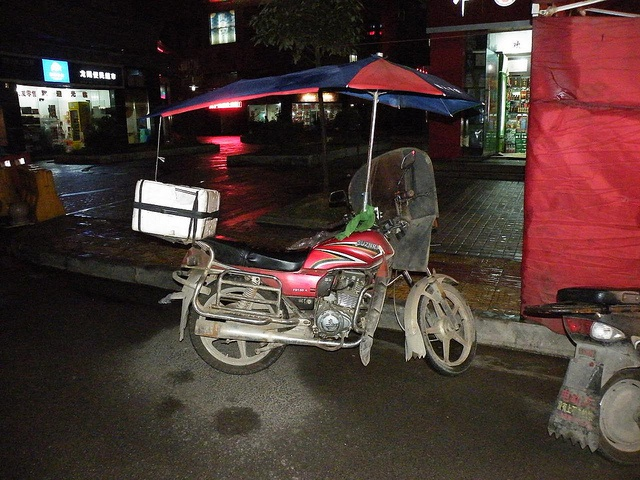Describe the objects in this image and their specific colors. I can see truck in black, brown, gray, and maroon tones, motorcycle in black, gray, and darkgray tones, and umbrella in black, navy, and brown tones in this image. 